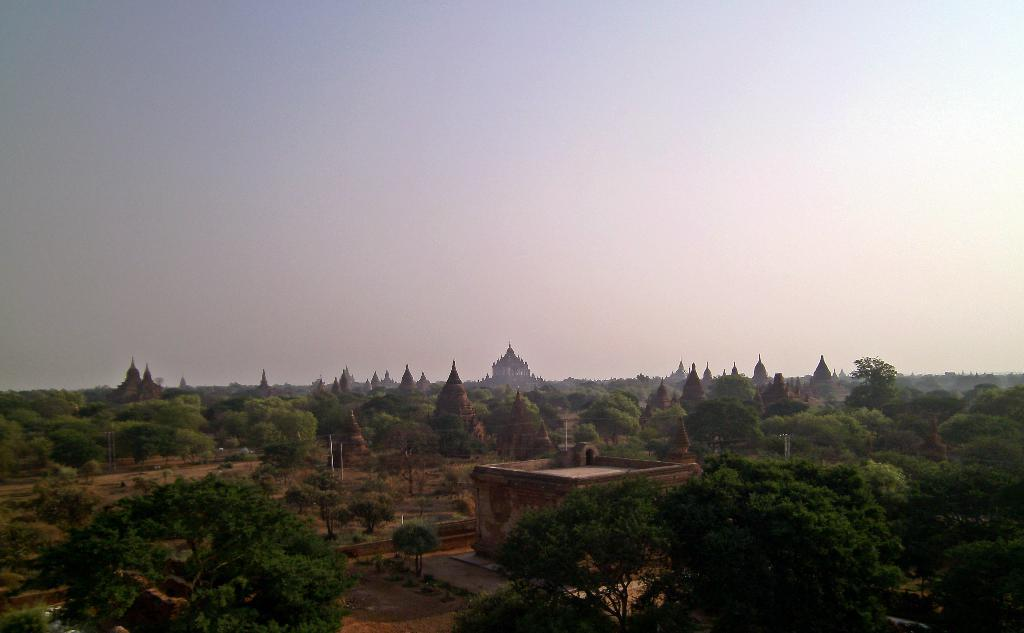What type of natural elements can be seen in the image? There are lots of trees in the image. What type of man-made structures are present in the image? There are buildings in the image. What is visible at the top of the image? The sky is clear and visible at the top of the image. What type of current can be seen flowing through the trees in the image? There is no current flowing through the trees in the image; it is a still image. What type of disgusting object can be seen in the image? There is no disgusting object present in the image. 